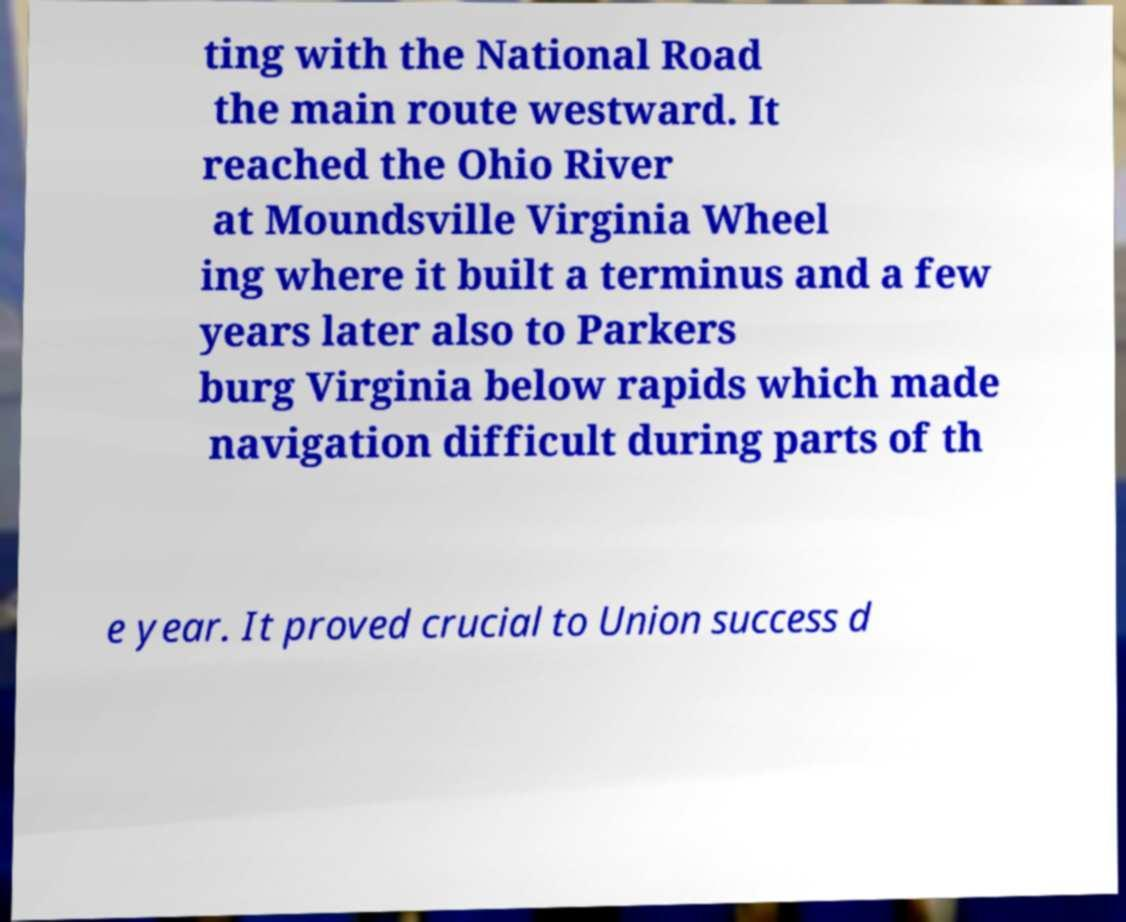Please identify and transcribe the text found in this image. ting with the National Road the main route westward. It reached the Ohio River at Moundsville Virginia Wheel ing where it built a terminus and a few years later also to Parkers burg Virginia below rapids which made navigation difficult during parts of th e year. It proved crucial to Union success d 